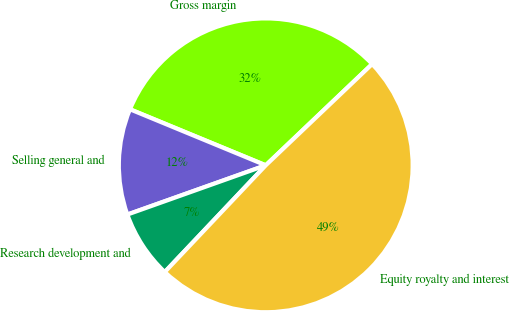<chart> <loc_0><loc_0><loc_500><loc_500><pie_chart><fcel>Gross margin<fcel>Selling general and<fcel>Research development and<fcel>Equity royalty and interest<nl><fcel>31.67%<fcel>11.67%<fcel>7.5%<fcel>49.17%<nl></chart> 